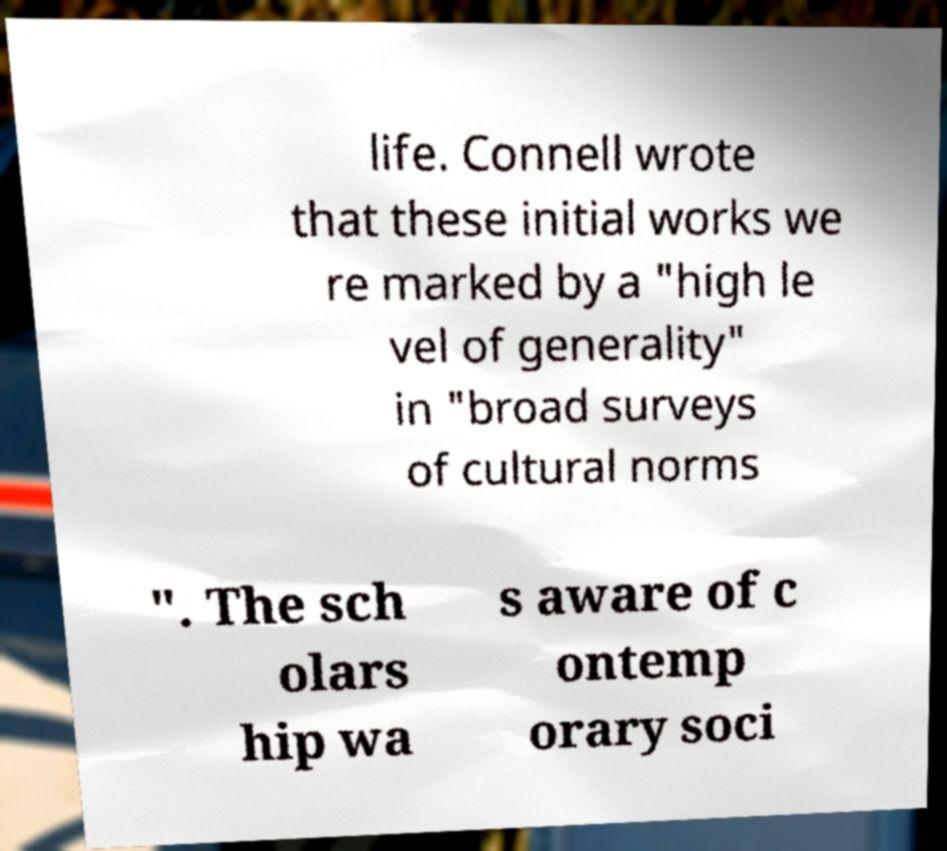I need the written content from this picture converted into text. Can you do that? life. Connell wrote that these initial works we re marked by a "high le vel of generality" in "broad surveys of cultural norms ". The sch olars hip wa s aware of c ontemp orary soci 